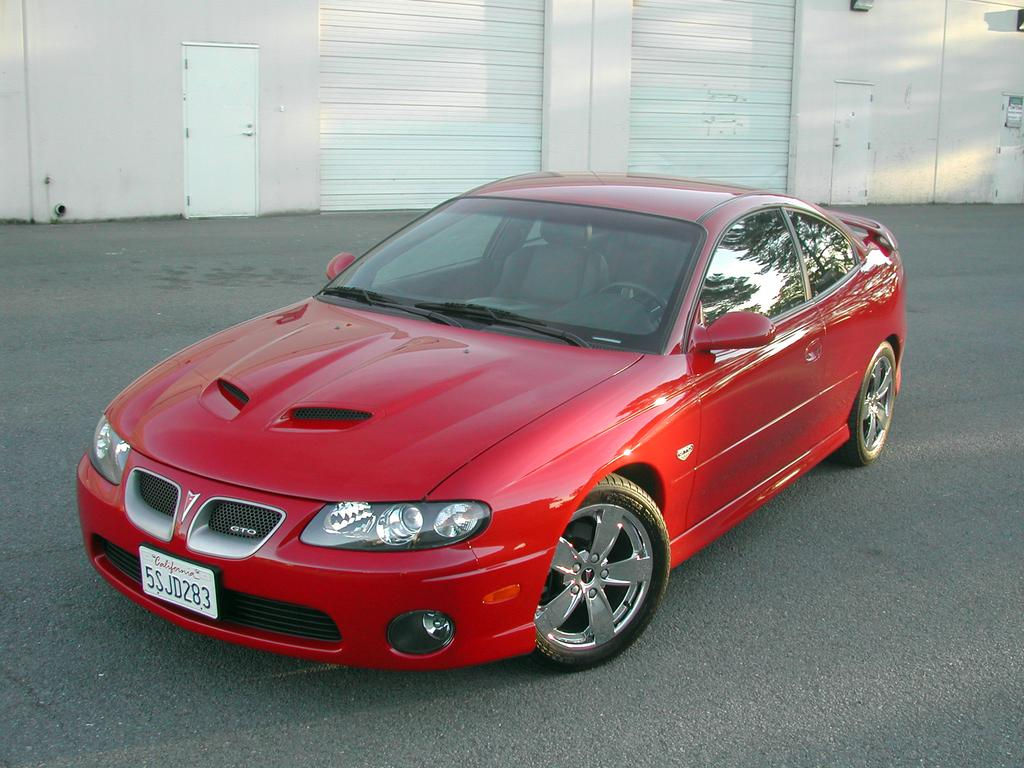What color is the car in the image? The car in the image is red. What can be seen beneath the car in the image? The ground is visible in the image. What type of structure is present in the image? There is a wall with some objects in the image. What are the shutters and doors in the image used for? The shutters and doors in the image are likely used for accessing or securing the structure. What type of behavior does the father exhibit in the image? There is no father present in the image, so it is not possible to comment on his behavior. 